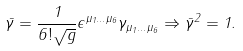<formula> <loc_0><loc_0><loc_500><loc_500>\bar { \gamma } = \frac { 1 } { 6 ! \sqrt { g } } \epsilon ^ { \mu _ { 1 } \dots \mu _ { 6 } } \gamma _ { \mu _ { 1 } \dots \mu _ { 6 } } \Rightarrow \bar { \gamma } ^ { 2 } = 1 .</formula> 